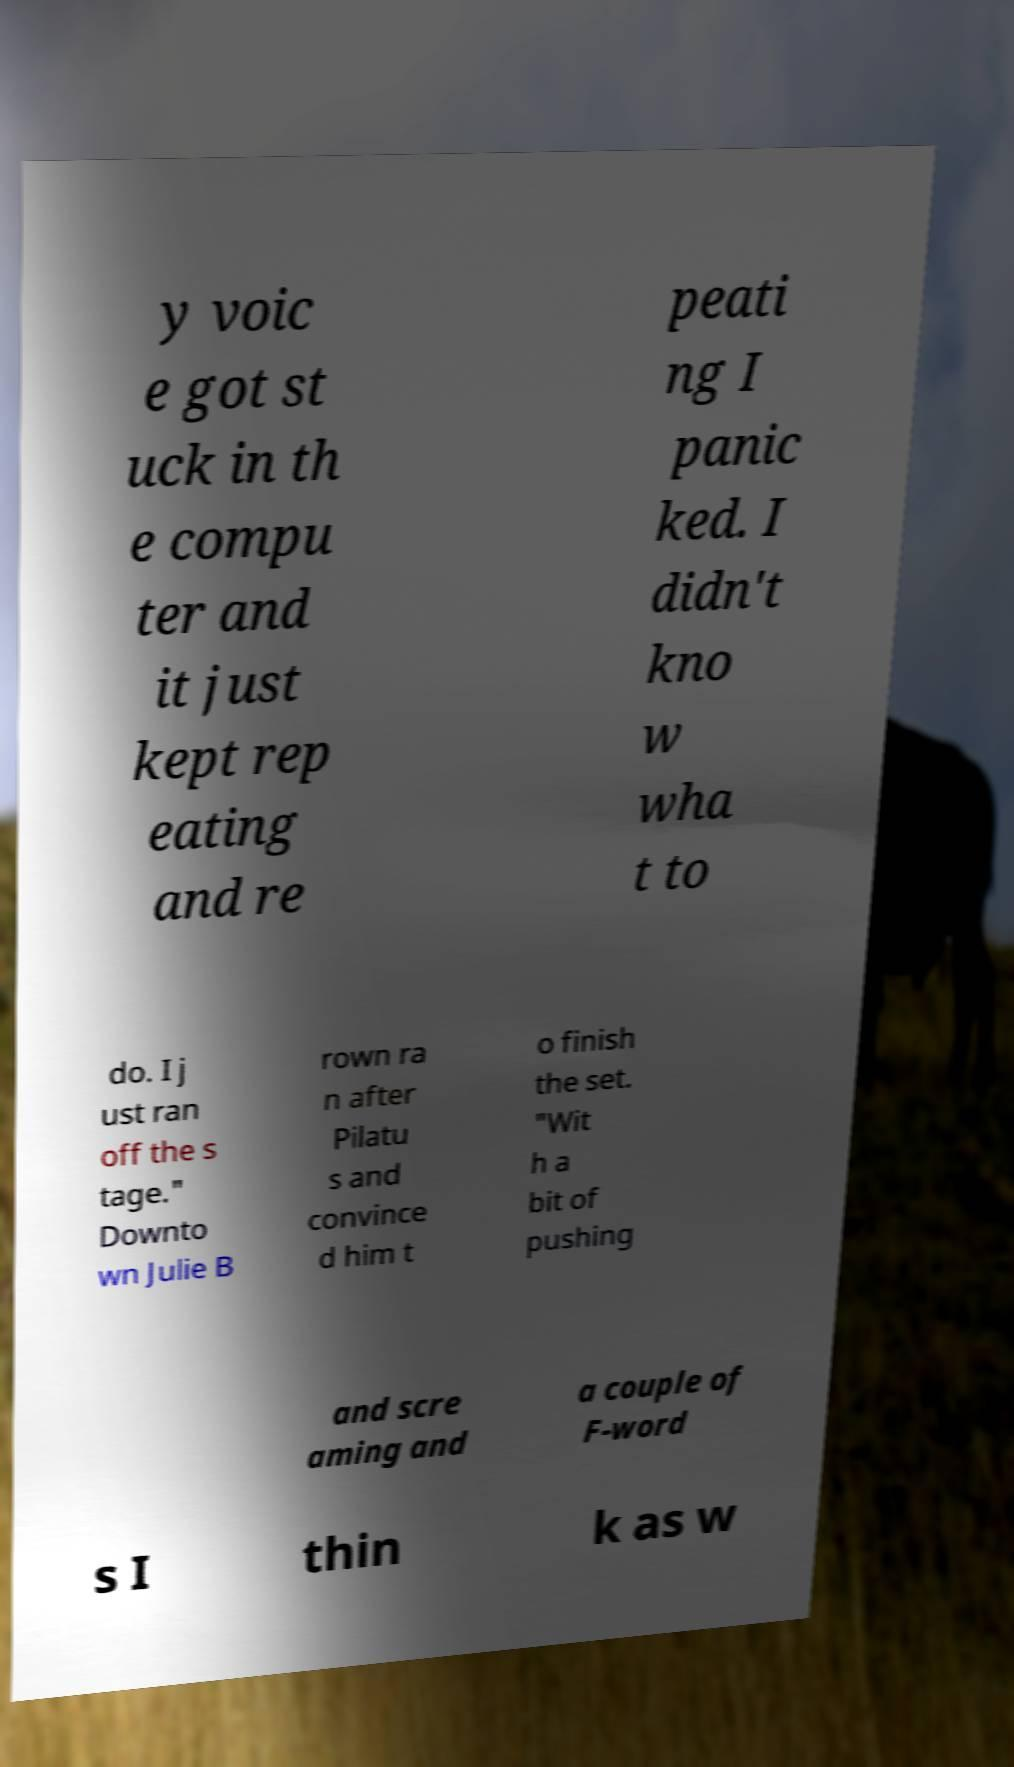For documentation purposes, I need the text within this image transcribed. Could you provide that? y voic e got st uck in th e compu ter and it just kept rep eating and re peati ng I panic ked. I didn't kno w wha t to do. I j ust ran off the s tage." Downto wn Julie B rown ra n after Pilatu s and convince d him t o finish the set. "Wit h a bit of pushing and scre aming and a couple of F-word s I thin k as w 